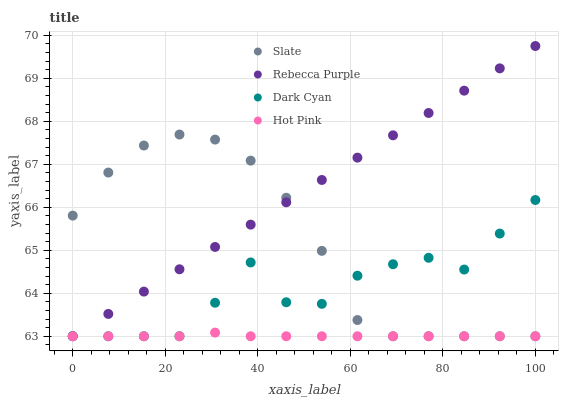Does Hot Pink have the minimum area under the curve?
Answer yes or no. Yes. Does Rebecca Purple have the maximum area under the curve?
Answer yes or no. Yes. Does Slate have the minimum area under the curve?
Answer yes or no. No. Does Slate have the maximum area under the curve?
Answer yes or no. No. Is Rebecca Purple the smoothest?
Answer yes or no. Yes. Is Dark Cyan the roughest?
Answer yes or no. Yes. Is Slate the smoothest?
Answer yes or no. No. Is Slate the roughest?
Answer yes or no. No. Does Dark Cyan have the lowest value?
Answer yes or no. Yes. Does Rebecca Purple have the highest value?
Answer yes or no. Yes. Does Slate have the highest value?
Answer yes or no. No. Does Rebecca Purple intersect Dark Cyan?
Answer yes or no. Yes. Is Rebecca Purple less than Dark Cyan?
Answer yes or no. No. Is Rebecca Purple greater than Dark Cyan?
Answer yes or no. No. 